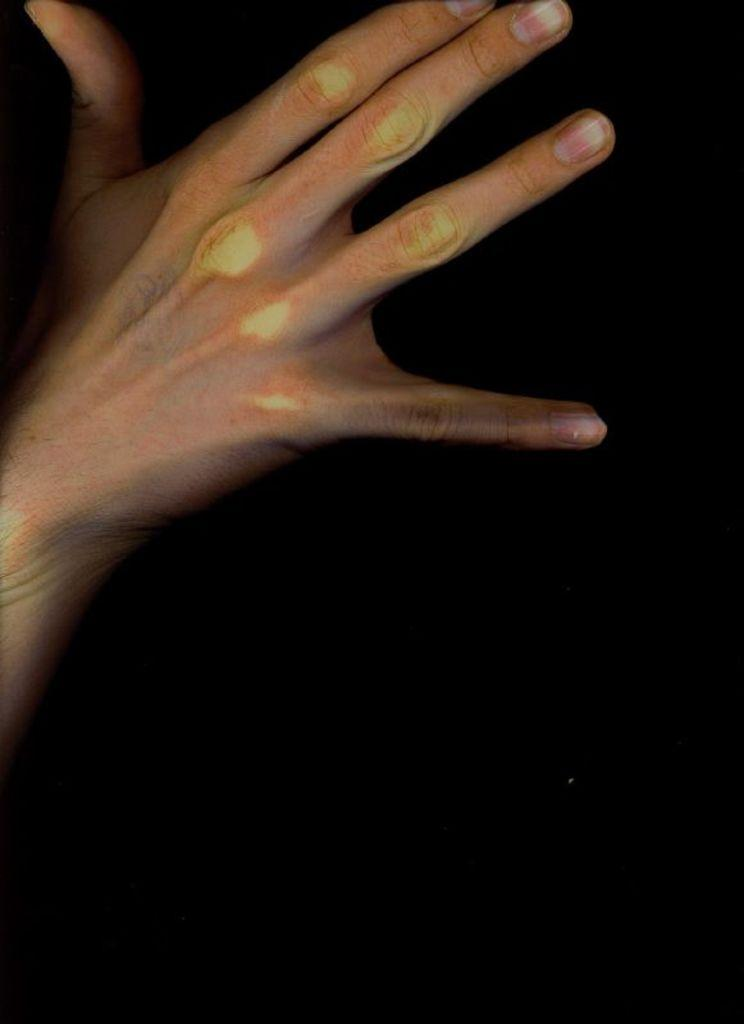What part of a person's body is visible in the image? There is a person's hand in the image. What can be observed about the lighting or color of the background in the image? The background of the image is dark. What type of letter is being held by the person in the image? There is no letter present in the image; only a person's hand is visible. What is the position of the sun in the image? The sun is not visible in the image, as the background is dark. 